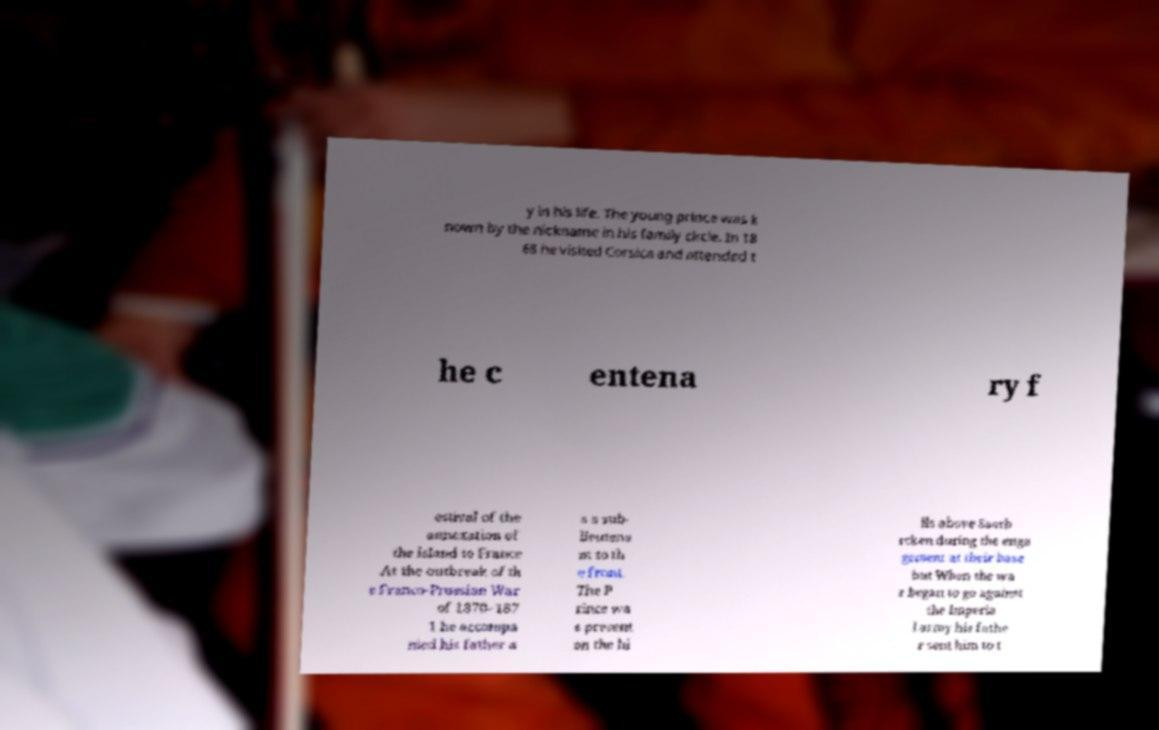Could you extract and type out the text from this image? y in his life. The young prince was k nown by the nickname in his family circle. In 18 68 he visited Corsica and attended t he c entena ry f estival of the annexation of the island to France .At the outbreak of th e Franco-Prussian War of 1870–187 1 he accompa nied his father a s a sub- lieutena nt to th e front. The P rince wa s present on the hi lls above Saarb rcken during the enga gement at their base but When the wa r began to go against the Imperia l army his fathe r sent him to t 